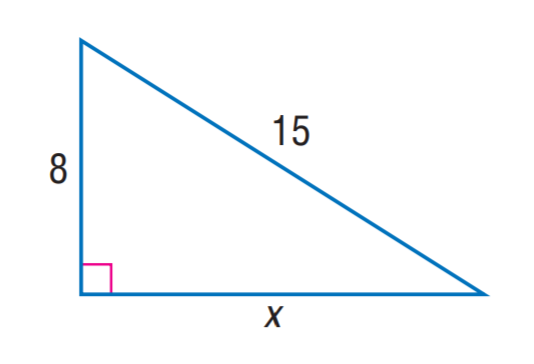Question: Find x. Round to the nearest tenth.
Choices:
A. 11.7
B. 12.7
C. 13.3
D. 13.7
Answer with the letter. Answer: B 